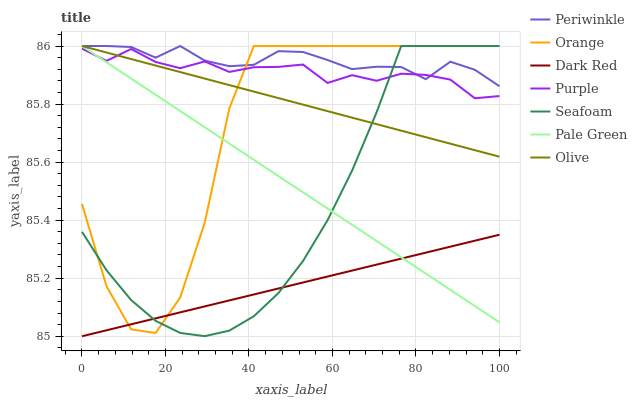Does Seafoam have the minimum area under the curve?
Answer yes or no. No. Does Seafoam have the maximum area under the curve?
Answer yes or no. No. Is Dark Red the smoothest?
Answer yes or no. No. Is Dark Red the roughest?
Answer yes or no. No. Does Seafoam have the lowest value?
Answer yes or no. No. Does Dark Red have the highest value?
Answer yes or no. No. Is Dark Red less than Purple?
Answer yes or no. Yes. Is Olive greater than Dark Red?
Answer yes or no. Yes. Does Dark Red intersect Purple?
Answer yes or no. No. 